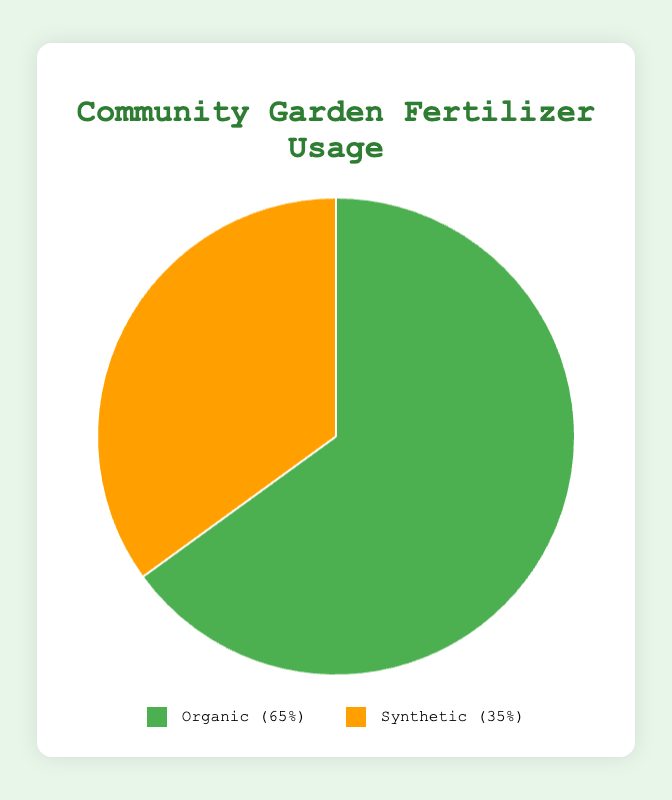1. What percentage of fertilizers used are organic? The pie chart shows that the slice representing organic fertilizers is labeled with a percentage. By observing this label, we can see the percentage.
Answer: 65% 2. What percentage of fertilizers used are synthetic? The pie chart has a slice that represents synthetic fertilizers. This slice is labeled with its percentage. Observing this label tells us the percentage.
Answer: 35% 3. Which type of fertilizer is used more in the community garden? To determine which type is used more, compare the two percentages shown in the pie chart. The larger percentage indicates the more frequently used type.
Answer: Organic 4. By how much does the organic fertilizer usage exceed the synthetic fertilizer usage? To find out how much more organic fertilizers are used compared to synthetic, subtract the percentage of synthetic fertilizers from the percentage of organic fertilizers. 65% - 35% = 30%
Answer: 30% 5. What is the ratio of organic to synthetic fertilizer usage? To find the ratio, divide the percentage of organic fertilizers by the percentage of synthetic fertilizers: 65 / 35 = 1.857, which can be approximated as 1.86:1.
Answer: 1.86:1 6. Which color represents synthetic fertilizers in the chart? The pie chart includes a color legend. Observing the legend tells us that synthetic fertilizers are represented by the color associated with it.
Answer: Orange 7. If the garden decides to increase synthetic fertilizer usage to 50%, what would the percentage of organic fertilizer usage become? In a pie chart, the total percentage must always sum to 100%. If synthetic fertilizer usage is increased to 50%, then the remaining percentage for organic fertilizers would be 100% - 50% = 50%.
Answer: 50% 8. What are some examples of organic fertilizers listed in the chart? By looking at the labels or legend, identify the organic fertilizer part and then note down the examples listed under this category.
Answer: Compost, Manure, Bone Meal, Blood Meal, Fish Emulsion 9. How would the chart change if organic fertilizer usage decreased by 15%? First, find the new percentage for organic fertilizers: 65% - 15% = 50%. Then, the percentage for synthetic fertilizers would increase by the same amount to maintain a total of 100%, so it becomes 35% + 15% = 50%.
Answer: Both Organic and Synthetic would be at 50% 10. If the community garden adds a new type of fertilizer that represents 10% of the total usage and this percentage is taken equally from the current organic and synthetic usage, what would be the new percentages for organic and synthetic fertilizers? First, determine how much each will decrease by: 10% / 2 = 5%. Then, subtract this from both original percentages: Organic: 65% - 5% = 60%, Synthetic: 35% - 5% = 30%.
Answer: Organic 60%, Synthetic 30% 